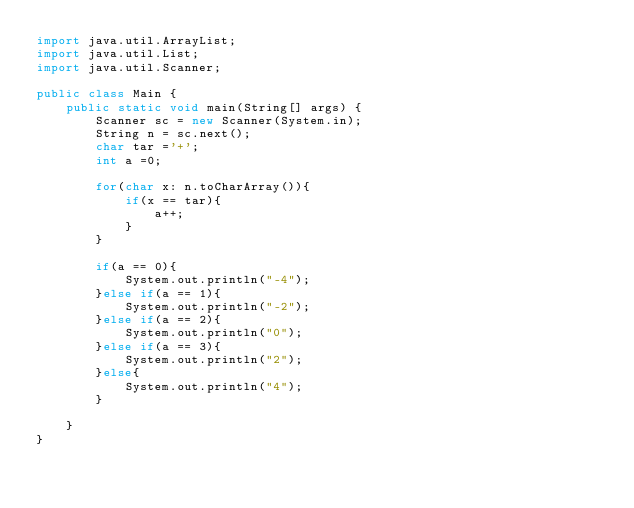Convert code to text. <code><loc_0><loc_0><loc_500><loc_500><_Java_>import java.util.ArrayList;
import java.util.List;
import java.util.Scanner;

public class Main {
    public static void main(String[] args) {
        Scanner sc = new Scanner(System.in);
        String n = sc.next();
        char tar ='+';
        int a =0;

        for(char x: n.toCharArray()){
            if(x == tar){
                a++;
            }
        }

        if(a == 0){
            System.out.println("-4");
        }else if(a == 1){
            System.out.println("-2");
        }else if(a == 2){
            System.out.println("0");
        }else if(a == 3){
            System.out.println("2");
        }else{
            System.out.println("4");
        }

    }
}
</code> 